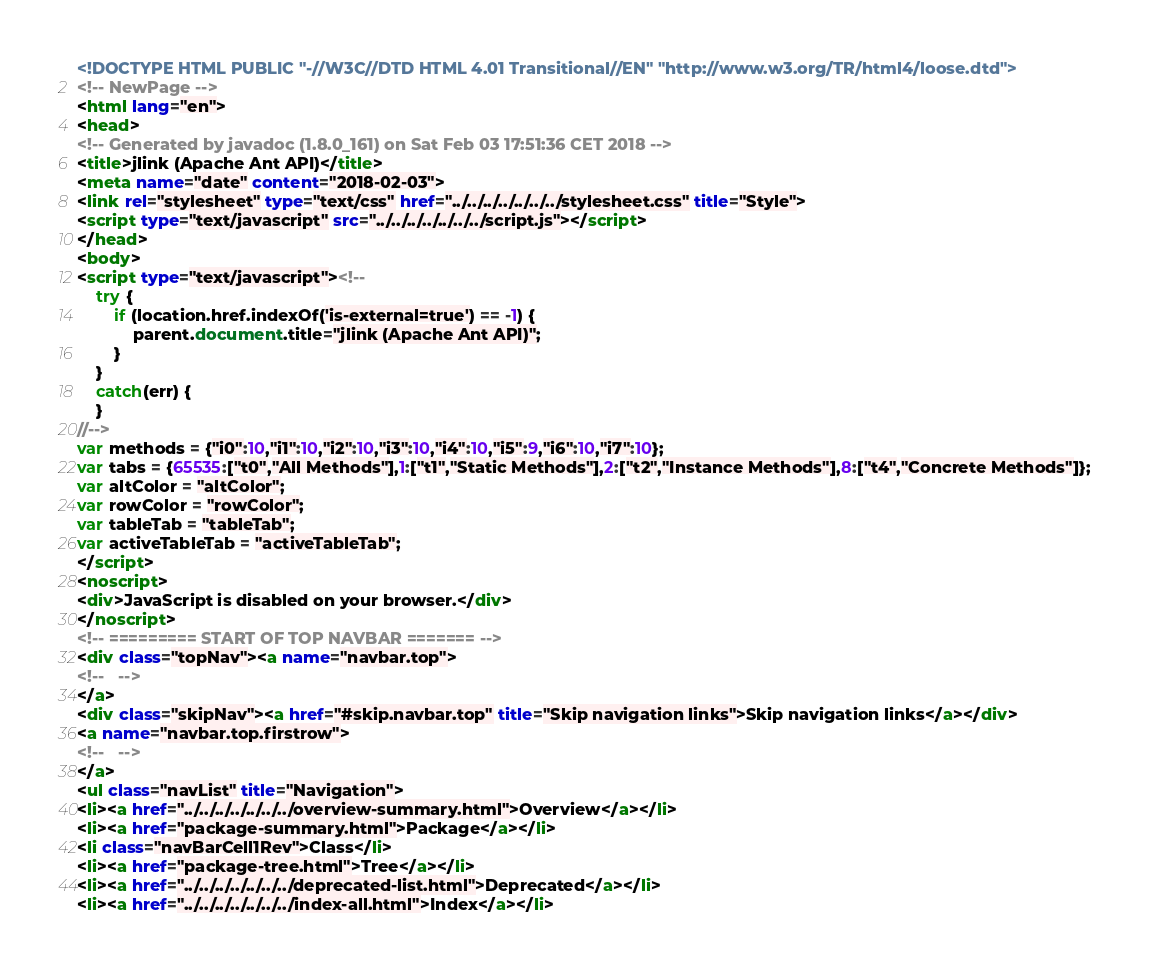<code> <loc_0><loc_0><loc_500><loc_500><_HTML_><!DOCTYPE HTML PUBLIC "-//W3C//DTD HTML 4.01 Transitional//EN" "http://www.w3.org/TR/html4/loose.dtd">
<!-- NewPage -->
<html lang="en">
<head>
<!-- Generated by javadoc (1.8.0_161) on Sat Feb 03 17:51:36 CET 2018 -->
<title>jlink (Apache Ant API)</title>
<meta name="date" content="2018-02-03">
<link rel="stylesheet" type="text/css" href="../../../../../../../stylesheet.css" title="Style">
<script type="text/javascript" src="../../../../../../../script.js"></script>
</head>
<body>
<script type="text/javascript"><!--
    try {
        if (location.href.indexOf('is-external=true') == -1) {
            parent.document.title="jlink (Apache Ant API)";
        }
    }
    catch(err) {
    }
//-->
var methods = {"i0":10,"i1":10,"i2":10,"i3":10,"i4":10,"i5":9,"i6":10,"i7":10};
var tabs = {65535:["t0","All Methods"],1:["t1","Static Methods"],2:["t2","Instance Methods"],8:["t4","Concrete Methods"]};
var altColor = "altColor";
var rowColor = "rowColor";
var tableTab = "tableTab";
var activeTableTab = "activeTableTab";
</script>
<noscript>
<div>JavaScript is disabled on your browser.</div>
</noscript>
<!-- ========= START OF TOP NAVBAR ======= -->
<div class="topNav"><a name="navbar.top">
<!--   -->
</a>
<div class="skipNav"><a href="#skip.navbar.top" title="Skip navigation links">Skip navigation links</a></div>
<a name="navbar.top.firstrow">
<!--   -->
</a>
<ul class="navList" title="Navigation">
<li><a href="../../../../../../../overview-summary.html">Overview</a></li>
<li><a href="package-summary.html">Package</a></li>
<li class="navBarCell1Rev">Class</li>
<li><a href="package-tree.html">Tree</a></li>
<li><a href="../../../../../../../deprecated-list.html">Deprecated</a></li>
<li><a href="../../../../../../../index-all.html">Index</a></li></code> 